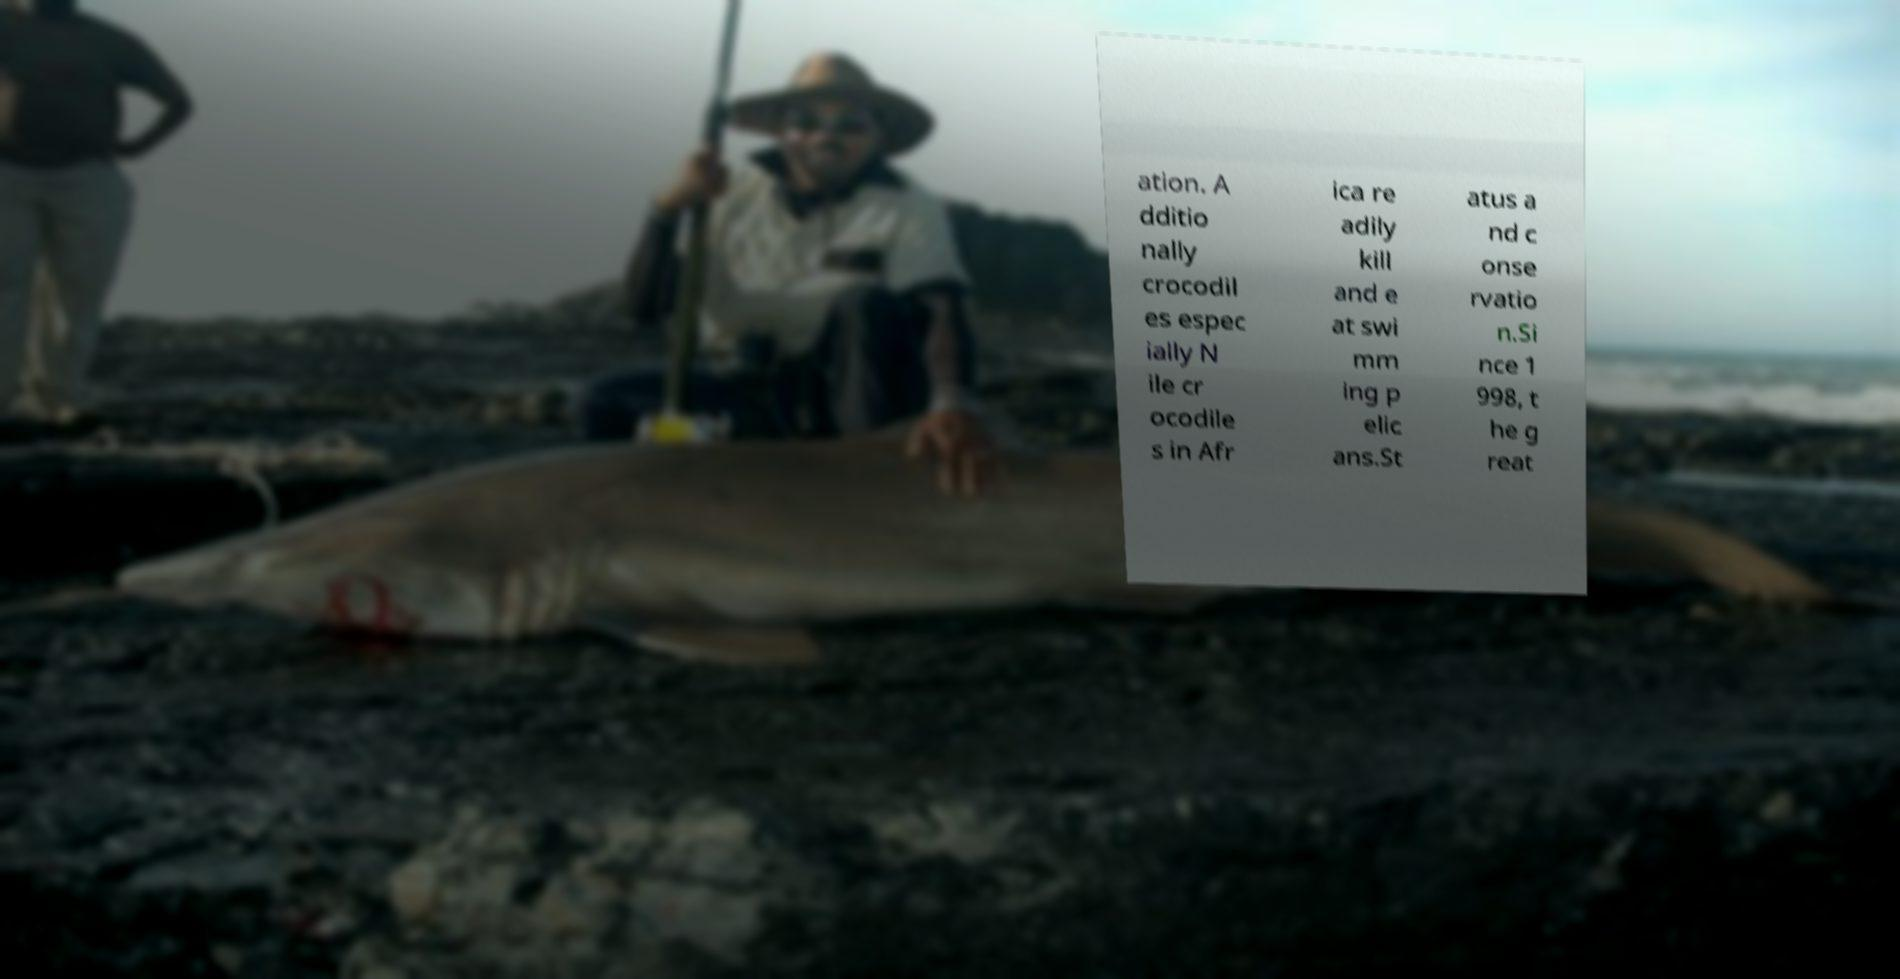Please identify and transcribe the text found in this image. ation. A dditio nally crocodil es espec ially N ile cr ocodile s in Afr ica re adily kill and e at swi mm ing p elic ans.St atus a nd c onse rvatio n.Si nce 1 998, t he g reat 